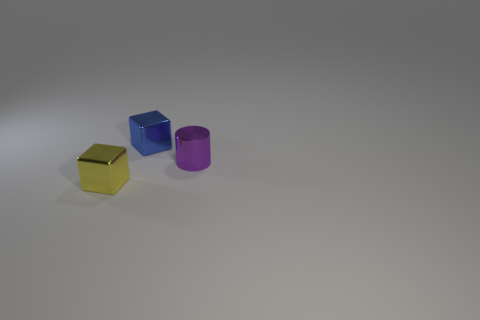Is there any other thing that is the same color as the tiny metal cylinder?
Give a very brief answer. No. How many things are shiny cylinders or small shiny objects behind the tiny yellow metal block?
Your answer should be compact. 2. What number of other objects are the same shape as the purple object?
Your response must be concise. 0. What number of yellow things are either cylinders or tiny metal objects?
Give a very brief answer. 1. There is a cube in front of the small blue metallic block; does it have the same color as the small metallic cylinder?
Give a very brief answer. No. What shape is the tiny purple object that is made of the same material as the tiny blue cube?
Offer a very short reply. Cylinder. There is a metal object that is left of the metallic cylinder and in front of the tiny blue thing; what color is it?
Provide a succinct answer. Yellow. Is the number of cubes that are behind the blue metal thing the same as the number of purple metal objects?
Keep it short and to the point. No. How many big purple metal blocks are there?
Provide a short and direct response. 0. What shape is the metallic thing that is behind the yellow metal cube and left of the purple metallic thing?
Provide a succinct answer. Cube. 